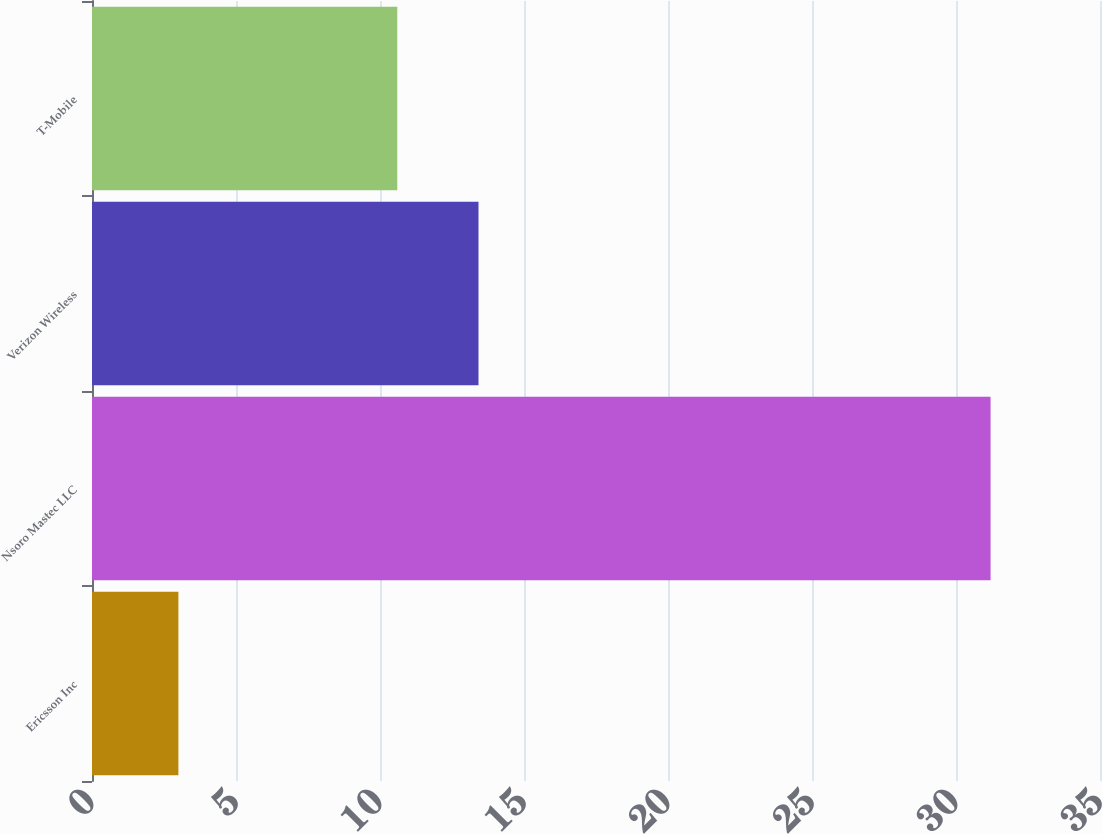Convert chart to OTSL. <chart><loc_0><loc_0><loc_500><loc_500><bar_chart><fcel>Ericsson Inc<fcel>Nsoro Mastec LLC<fcel>Verizon Wireless<fcel>T-Mobile<nl><fcel>3<fcel>31.2<fcel>13.42<fcel>10.6<nl></chart> 